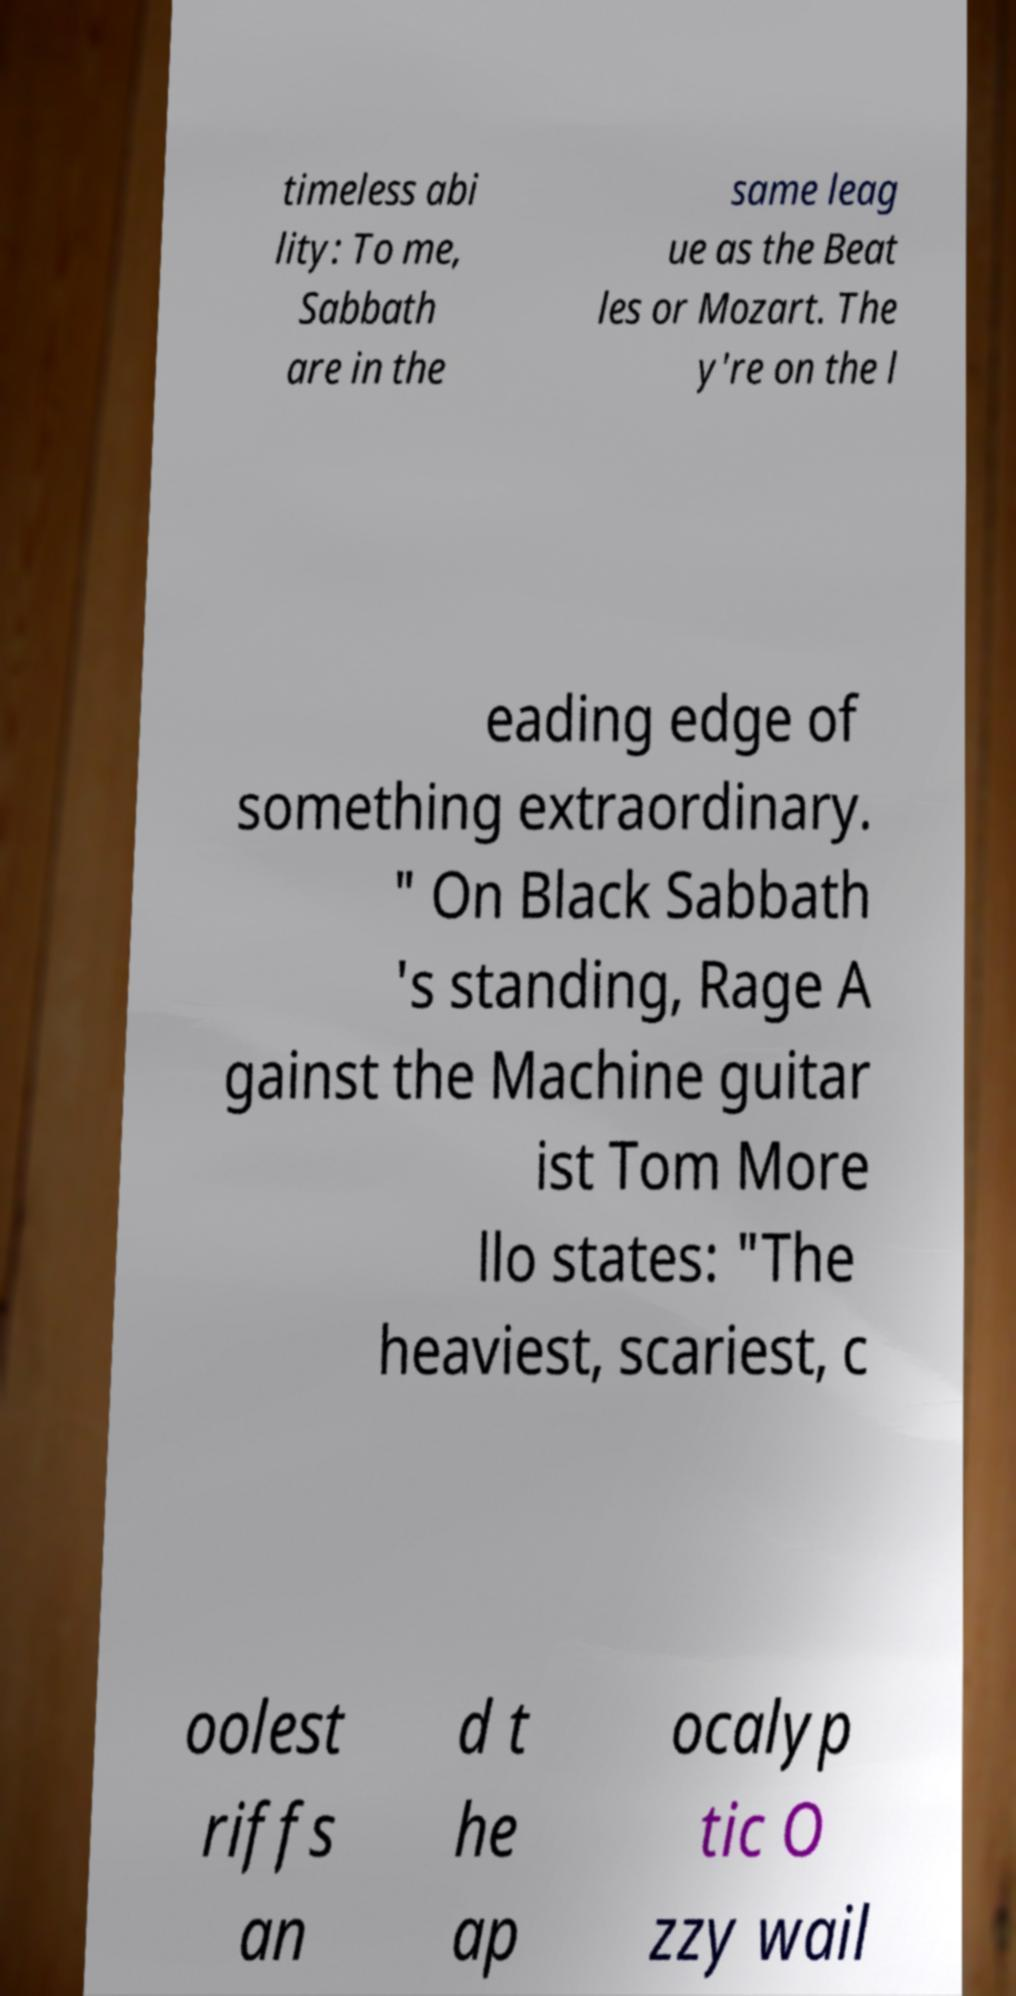Can you read and provide the text displayed in the image?This photo seems to have some interesting text. Can you extract and type it out for me? timeless abi lity: To me, Sabbath are in the same leag ue as the Beat les or Mozart. The y're on the l eading edge of something extraordinary. " On Black Sabbath 's standing, Rage A gainst the Machine guitar ist Tom More llo states: "The heaviest, scariest, c oolest riffs an d t he ap ocalyp tic O zzy wail 